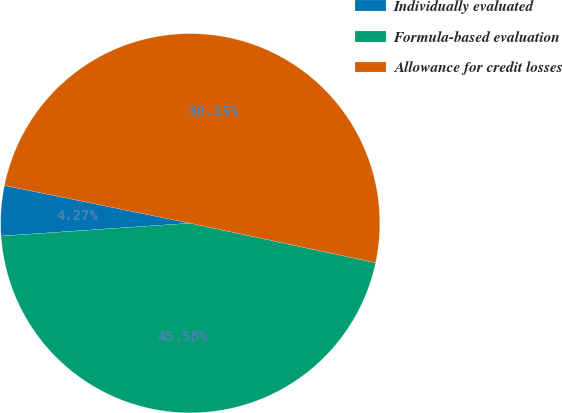Convert chart. <chart><loc_0><loc_0><loc_500><loc_500><pie_chart><fcel>Individually evaluated<fcel>Formula-based evaluation<fcel>Allowance for credit losses<nl><fcel>4.27%<fcel>45.58%<fcel>50.14%<nl></chart> 